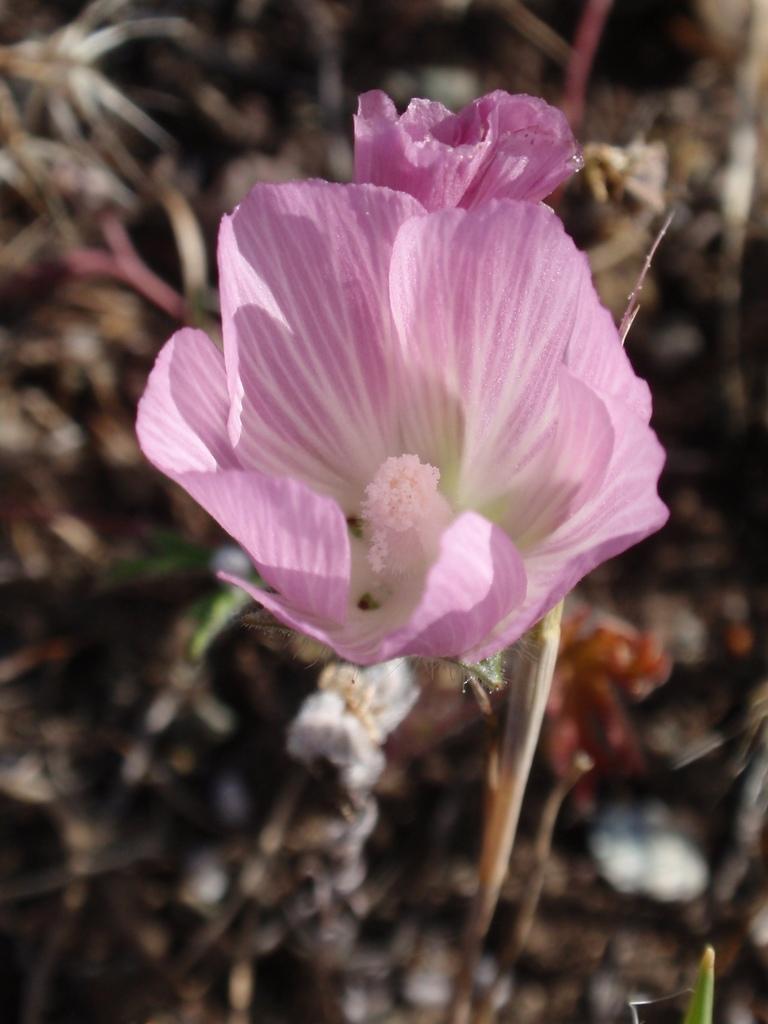Can you describe this image briefly? In this image I can see pink and white color flower. Back I can see brown color and blurred background. 